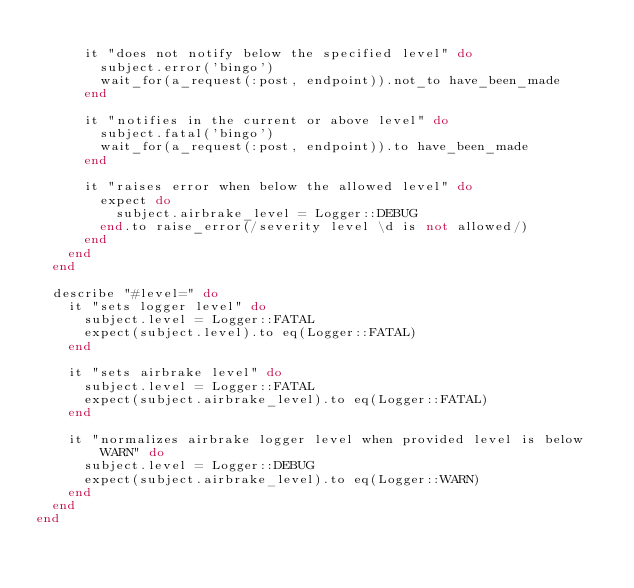Convert code to text. <code><loc_0><loc_0><loc_500><loc_500><_Ruby_>
      it "does not notify below the specified level" do
        subject.error('bingo')
        wait_for(a_request(:post, endpoint)).not_to have_been_made
      end

      it "notifies in the current or above level" do
        subject.fatal('bingo')
        wait_for(a_request(:post, endpoint)).to have_been_made
      end

      it "raises error when below the allowed level" do
        expect do
          subject.airbrake_level = Logger::DEBUG
        end.to raise_error(/severity level \d is not allowed/)
      end
    end
  end

  describe "#level=" do
    it "sets logger level" do
      subject.level = Logger::FATAL
      expect(subject.level).to eq(Logger::FATAL)
    end

    it "sets airbrake level" do
      subject.level = Logger::FATAL
      expect(subject.airbrake_level).to eq(Logger::FATAL)
    end

    it "normalizes airbrake logger level when provided level is below WARN" do
      subject.level = Logger::DEBUG
      expect(subject.airbrake_level).to eq(Logger::WARN)
    end
  end
end
</code> 